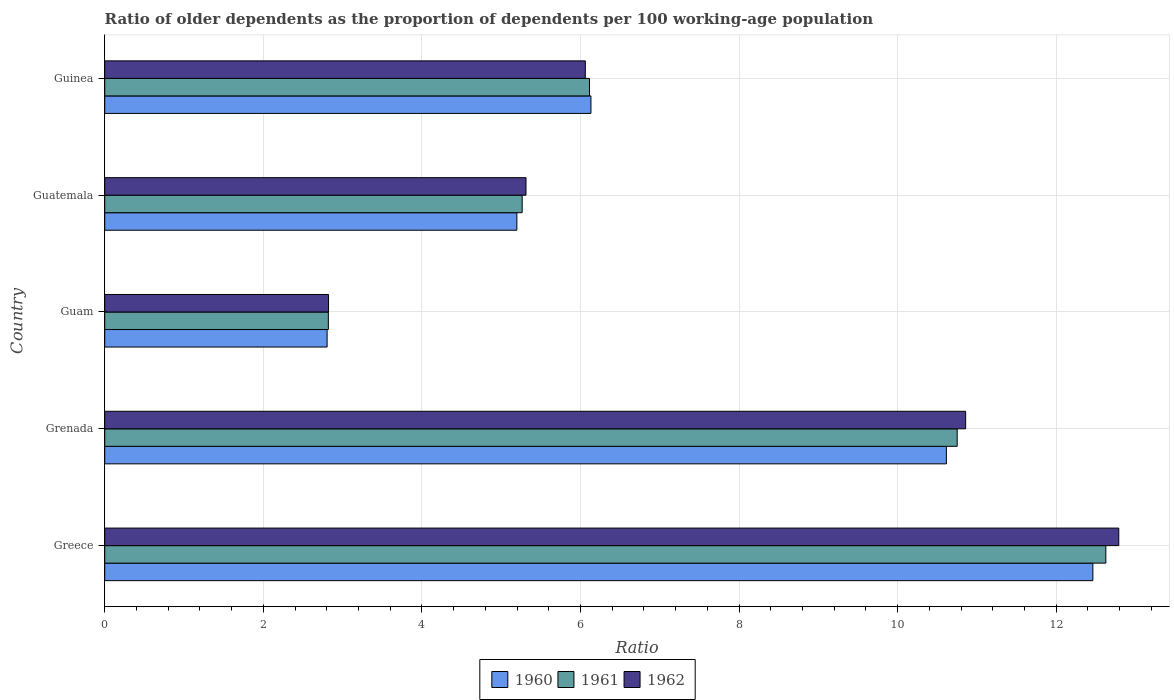How many groups of bars are there?
Give a very brief answer. 5. Are the number of bars per tick equal to the number of legend labels?
Your answer should be very brief. Yes. Are the number of bars on each tick of the Y-axis equal?
Give a very brief answer. Yes. How many bars are there on the 5th tick from the top?
Provide a short and direct response. 3. What is the label of the 3rd group of bars from the top?
Keep it short and to the point. Guam. What is the age dependency ratio(old) in 1961 in Greece?
Provide a short and direct response. 12.63. Across all countries, what is the maximum age dependency ratio(old) in 1960?
Your answer should be compact. 12.46. Across all countries, what is the minimum age dependency ratio(old) in 1962?
Give a very brief answer. 2.82. In which country was the age dependency ratio(old) in 1960 maximum?
Ensure brevity in your answer.  Greece. In which country was the age dependency ratio(old) in 1962 minimum?
Keep it short and to the point. Guam. What is the total age dependency ratio(old) in 1962 in the graph?
Your response must be concise. 37.84. What is the difference between the age dependency ratio(old) in 1960 in Greece and that in Grenada?
Keep it short and to the point. 1.85. What is the difference between the age dependency ratio(old) in 1960 in Guam and the age dependency ratio(old) in 1962 in Guinea?
Provide a succinct answer. -3.26. What is the average age dependency ratio(old) in 1960 per country?
Provide a succinct answer. 7.44. What is the difference between the age dependency ratio(old) in 1962 and age dependency ratio(old) in 1961 in Guatemala?
Give a very brief answer. 0.05. What is the ratio of the age dependency ratio(old) in 1962 in Grenada to that in Guinea?
Ensure brevity in your answer.  1.79. Is the age dependency ratio(old) in 1961 in Greece less than that in Guam?
Provide a short and direct response. No. Is the difference between the age dependency ratio(old) in 1962 in Grenada and Guinea greater than the difference between the age dependency ratio(old) in 1961 in Grenada and Guinea?
Your answer should be very brief. Yes. What is the difference between the highest and the second highest age dependency ratio(old) in 1961?
Offer a terse response. 1.87. What is the difference between the highest and the lowest age dependency ratio(old) in 1961?
Your answer should be compact. 9.81. In how many countries, is the age dependency ratio(old) in 1960 greater than the average age dependency ratio(old) in 1960 taken over all countries?
Offer a terse response. 2. Is the sum of the age dependency ratio(old) in 1962 in Grenada and Guinea greater than the maximum age dependency ratio(old) in 1960 across all countries?
Provide a succinct answer. Yes. What does the 1st bar from the top in Grenada represents?
Give a very brief answer. 1962. How many bars are there?
Keep it short and to the point. 15. How many countries are there in the graph?
Your answer should be compact. 5. What is the difference between two consecutive major ticks on the X-axis?
Your answer should be very brief. 2. Does the graph contain any zero values?
Keep it short and to the point. No. How many legend labels are there?
Your answer should be very brief. 3. How are the legend labels stacked?
Your response must be concise. Horizontal. What is the title of the graph?
Your response must be concise. Ratio of older dependents as the proportion of dependents per 100 working-age population. Does "1970" appear as one of the legend labels in the graph?
Provide a short and direct response. No. What is the label or title of the X-axis?
Your answer should be very brief. Ratio. What is the label or title of the Y-axis?
Make the answer very short. Country. What is the Ratio of 1960 in Greece?
Provide a short and direct response. 12.46. What is the Ratio of 1961 in Greece?
Make the answer very short. 12.63. What is the Ratio in 1962 in Greece?
Provide a short and direct response. 12.79. What is the Ratio in 1960 in Grenada?
Provide a succinct answer. 10.61. What is the Ratio in 1961 in Grenada?
Make the answer very short. 10.75. What is the Ratio in 1962 in Grenada?
Keep it short and to the point. 10.86. What is the Ratio of 1960 in Guam?
Provide a succinct answer. 2.8. What is the Ratio of 1961 in Guam?
Offer a terse response. 2.82. What is the Ratio in 1962 in Guam?
Give a very brief answer. 2.82. What is the Ratio in 1960 in Guatemala?
Offer a terse response. 5.2. What is the Ratio of 1961 in Guatemala?
Your answer should be compact. 5.26. What is the Ratio in 1962 in Guatemala?
Give a very brief answer. 5.31. What is the Ratio of 1960 in Guinea?
Your response must be concise. 6.13. What is the Ratio of 1961 in Guinea?
Provide a succinct answer. 6.11. What is the Ratio in 1962 in Guinea?
Make the answer very short. 6.06. Across all countries, what is the maximum Ratio of 1960?
Provide a succinct answer. 12.46. Across all countries, what is the maximum Ratio in 1961?
Offer a terse response. 12.63. Across all countries, what is the maximum Ratio of 1962?
Your response must be concise. 12.79. Across all countries, what is the minimum Ratio of 1960?
Offer a very short reply. 2.8. Across all countries, what is the minimum Ratio in 1961?
Your answer should be very brief. 2.82. Across all countries, what is the minimum Ratio in 1962?
Your answer should be very brief. 2.82. What is the total Ratio of 1960 in the graph?
Your answer should be compact. 37.21. What is the total Ratio in 1961 in the graph?
Keep it short and to the point. 37.57. What is the total Ratio of 1962 in the graph?
Provide a short and direct response. 37.84. What is the difference between the Ratio in 1960 in Greece and that in Grenada?
Your answer should be compact. 1.85. What is the difference between the Ratio in 1961 in Greece and that in Grenada?
Ensure brevity in your answer.  1.87. What is the difference between the Ratio in 1962 in Greece and that in Grenada?
Your answer should be very brief. 1.93. What is the difference between the Ratio in 1960 in Greece and that in Guam?
Provide a succinct answer. 9.66. What is the difference between the Ratio in 1961 in Greece and that in Guam?
Your answer should be very brief. 9.81. What is the difference between the Ratio of 1962 in Greece and that in Guam?
Give a very brief answer. 9.97. What is the difference between the Ratio of 1960 in Greece and that in Guatemala?
Your response must be concise. 7.26. What is the difference between the Ratio in 1961 in Greece and that in Guatemala?
Offer a terse response. 7.36. What is the difference between the Ratio in 1962 in Greece and that in Guatemala?
Keep it short and to the point. 7.48. What is the difference between the Ratio in 1960 in Greece and that in Guinea?
Provide a succinct answer. 6.33. What is the difference between the Ratio of 1961 in Greece and that in Guinea?
Your answer should be very brief. 6.51. What is the difference between the Ratio of 1962 in Greece and that in Guinea?
Make the answer very short. 6.73. What is the difference between the Ratio of 1960 in Grenada and that in Guam?
Ensure brevity in your answer.  7.81. What is the difference between the Ratio in 1961 in Grenada and that in Guam?
Provide a succinct answer. 7.93. What is the difference between the Ratio of 1962 in Grenada and that in Guam?
Provide a short and direct response. 8.03. What is the difference between the Ratio of 1960 in Grenada and that in Guatemala?
Your response must be concise. 5.42. What is the difference between the Ratio in 1961 in Grenada and that in Guatemala?
Give a very brief answer. 5.49. What is the difference between the Ratio in 1962 in Grenada and that in Guatemala?
Make the answer very short. 5.54. What is the difference between the Ratio in 1960 in Grenada and that in Guinea?
Your answer should be compact. 4.48. What is the difference between the Ratio of 1961 in Grenada and that in Guinea?
Offer a terse response. 4.64. What is the difference between the Ratio in 1962 in Grenada and that in Guinea?
Your response must be concise. 4.8. What is the difference between the Ratio of 1960 in Guam and that in Guatemala?
Your response must be concise. -2.39. What is the difference between the Ratio in 1961 in Guam and that in Guatemala?
Offer a very short reply. -2.44. What is the difference between the Ratio in 1962 in Guam and that in Guatemala?
Keep it short and to the point. -2.49. What is the difference between the Ratio of 1960 in Guam and that in Guinea?
Provide a short and direct response. -3.33. What is the difference between the Ratio in 1961 in Guam and that in Guinea?
Offer a terse response. -3.29. What is the difference between the Ratio of 1962 in Guam and that in Guinea?
Give a very brief answer. -3.24. What is the difference between the Ratio in 1960 in Guatemala and that in Guinea?
Your answer should be very brief. -0.93. What is the difference between the Ratio in 1961 in Guatemala and that in Guinea?
Ensure brevity in your answer.  -0.85. What is the difference between the Ratio of 1962 in Guatemala and that in Guinea?
Ensure brevity in your answer.  -0.75. What is the difference between the Ratio of 1960 in Greece and the Ratio of 1961 in Grenada?
Ensure brevity in your answer.  1.71. What is the difference between the Ratio in 1960 in Greece and the Ratio in 1962 in Grenada?
Your answer should be compact. 1.6. What is the difference between the Ratio of 1961 in Greece and the Ratio of 1962 in Grenada?
Offer a very short reply. 1.77. What is the difference between the Ratio of 1960 in Greece and the Ratio of 1961 in Guam?
Provide a short and direct response. 9.64. What is the difference between the Ratio of 1960 in Greece and the Ratio of 1962 in Guam?
Your answer should be compact. 9.64. What is the difference between the Ratio of 1961 in Greece and the Ratio of 1962 in Guam?
Your response must be concise. 9.8. What is the difference between the Ratio of 1960 in Greece and the Ratio of 1961 in Guatemala?
Ensure brevity in your answer.  7.2. What is the difference between the Ratio in 1960 in Greece and the Ratio in 1962 in Guatemala?
Your answer should be very brief. 7.15. What is the difference between the Ratio in 1961 in Greece and the Ratio in 1962 in Guatemala?
Provide a short and direct response. 7.31. What is the difference between the Ratio of 1960 in Greece and the Ratio of 1961 in Guinea?
Offer a terse response. 6.35. What is the difference between the Ratio in 1960 in Greece and the Ratio in 1962 in Guinea?
Offer a very short reply. 6.4. What is the difference between the Ratio in 1961 in Greece and the Ratio in 1962 in Guinea?
Provide a succinct answer. 6.56. What is the difference between the Ratio of 1960 in Grenada and the Ratio of 1961 in Guam?
Provide a succinct answer. 7.79. What is the difference between the Ratio of 1960 in Grenada and the Ratio of 1962 in Guam?
Ensure brevity in your answer.  7.79. What is the difference between the Ratio in 1961 in Grenada and the Ratio in 1962 in Guam?
Make the answer very short. 7.93. What is the difference between the Ratio of 1960 in Grenada and the Ratio of 1961 in Guatemala?
Provide a succinct answer. 5.35. What is the difference between the Ratio in 1960 in Grenada and the Ratio in 1962 in Guatemala?
Provide a succinct answer. 5.3. What is the difference between the Ratio of 1961 in Grenada and the Ratio of 1962 in Guatemala?
Offer a very short reply. 5.44. What is the difference between the Ratio in 1960 in Grenada and the Ratio in 1961 in Guinea?
Your response must be concise. 4.5. What is the difference between the Ratio of 1960 in Grenada and the Ratio of 1962 in Guinea?
Keep it short and to the point. 4.55. What is the difference between the Ratio of 1961 in Grenada and the Ratio of 1962 in Guinea?
Your answer should be compact. 4.69. What is the difference between the Ratio in 1960 in Guam and the Ratio in 1961 in Guatemala?
Offer a very short reply. -2.46. What is the difference between the Ratio of 1960 in Guam and the Ratio of 1962 in Guatemala?
Give a very brief answer. -2.51. What is the difference between the Ratio of 1961 in Guam and the Ratio of 1962 in Guatemala?
Keep it short and to the point. -2.49. What is the difference between the Ratio in 1960 in Guam and the Ratio in 1961 in Guinea?
Your answer should be compact. -3.31. What is the difference between the Ratio of 1960 in Guam and the Ratio of 1962 in Guinea?
Keep it short and to the point. -3.26. What is the difference between the Ratio of 1961 in Guam and the Ratio of 1962 in Guinea?
Offer a terse response. -3.24. What is the difference between the Ratio of 1960 in Guatemala and the Ratio of 1961 in Guinea?
Provide a succinct answer. -0.92. What is the difference between the Ratio of 1960 in Guatemala and the Ratio of 1962 in Guinea?
Keep it short and to the point. -0.86. What is the difference between the Ratio in 1961 in Guatemala and the Ratio in 1962 in Guinea?
Offer a very short reply. -0.8. What is the average Ratio in 1960 per country?
Offer a terse response. 7.44. What is the average Ratio in 1961 per country?
Ensure brevity in your answer.  7.51. What is the average Ratio of 1962 per country?
Ensure brevity in your answer.  7.57. What is the difference between the Ratio of 1960 and Ratio of 1961 in Greece?
Your answer should be compact. -0.16. What is the difference between the Ratio of 1960 and Ratio of 1962 in Greece?
Give a very brief answer. -0.33. What is the difference between the Ratio in 1961 and Ratio in 1962 in Greece?
Ensure brevity in your answer.  -0.16. What is the difference between the Ratio in 1960 and Ratio in 1961 in Grenada?
Keep it short and to the point. -0.14. What is the difference between the Ratio in 1960 and Ratio in 1962 in Grenada?
Your answer should be very brief. -0.24. What is the difference between the Ratio in 1961 and Ratio in 1962 in Grenada?
Make the answer very short. -0.11. What is the difference between the Ratio of 1960 and Ratio of 1961 in Guam?
Your response must be concise. -0.02. What is the difference between the Ratio of 1960 and Ratio of 1962 in Guam?
Your answer should be compact. -0.02. What is the difference between the Ratio in 1961 and Ratio in 1962 in Guam?
Provide a short and direct response. -0. What is the difference between the Ratio in 1960 and Ratio in 1961 in Guatemala?
Offer a very short reply. -0.07. What is the difference between the Ratio of 1960 and Ratio of 1962 in Guatemala?
Your answer should be compact. -0.12. What is the difference between the Ratio in 1961 and Ratio in 1962 in Guatemala?
Make the answer very short. -0.05. What is the difference between the Ratio in 1960 and Ratio in 1961 in Guinea?
Give a very brief answer. 0.02. What is the difference between the Ratio in 1960 and Ratio in 1962 in Guinea?
Provide a short and direct response. 0.07. What is the difference between the Ratio in 1961 and Ratio in 1962 in Guinea?
Provide a succinct answer. 0.05. What is the ratio of the Ratio in 1960 in Greece to that in Grenada?
Make the answer very short. 1.17. What is the ratio of the Ratio in 1961 in Greece to that in Grenada?
Provide a succinct answer. 1.17. What is the ratio of the Ratio of 1962 in Greece to that in Grenada?
Offer a very short reply. 1.18. What is the ratio of the Ratio in 1960 in Greece to that in Guam?
Provide a short and direct response. 4.44. What is the ratio of the Ratio in 1961 in Greece to that in Guam?
Your answer should be compact. 4.48. What is the ratio of the Ratio in 1962 in Greece to that in Guam?
Make the answer very short. 4.53. What is the ratio of the Ratio in 1960 in Greece to that in Guatemala?
Keep it short and to the point. 2.4. What is the ratio of the Ratio of 1961 in Greece to that in Guatemala?
Provide a succinct answer. 2.4. What is the ratio of the Ratio in 1962 in Greece to that in Guatemala?
Your answer should be compact. 2.41. What is the ratio of the Ratio of 1960 in Greece to that in Guinea?
Provide a short and direct response. 2.03. What is the ratio of the Ratio in 1961 in Greece to that in Guinea?
Provide a succinct answer. 2.07. What is the ratio of the Ratio of 1962 in Greece to that in Guinea?
Give a very brief answer. 2.11. What is the ratio of the Ratio in 1960 in Grenada to that in Guam?
Your answer should be compact. 3.78. What is the ratio of the Ratio in 1961 in Grenada to that in Guam?
Keep it short and to the point. 3.81. What is the ratio of the Ratio of 1962 in Grenada to that in Guam?
Offer a very short reply. 3.85. What is the ratio of the Ratio of 1960 in Grenada to that in Guatemala?
Provide a short and direct response. 2.04. What is the ratio of the Ratio in 1961 in Grenada to that in Guatemala?
Your answer should be compact. 2.04. What is the ratio of the Ratio in 1962 in Grenada to that in Guatemala?
Your answer should be compact. 2.04. What is the ratio of the Ratio in 1960 in Grenada to that in Guinea?
Offer a terse response. 1.73. What is the ratio of the Ratio in 1961 in Grenada to that in Guinea?
Keep it short and to the point. 1.76. What is the ratio of the Ratio of 1962 in Grenada to that in Guinea?
Ensure brevity in your answer.  1.79. What is the ratio of the Ratio of 1960 in Guam to that in Guatemala?
Provide a short and direct response. 0.54. What is the ratio of the Ratio in 1961 in Guam to that in Guatemala?
Give a very brief answer. 0.54. What is the ratio of the Ratio of 1962 in Guam to that in Guatemala?
Your answer should be compact. 0.53. What is the ratio of the Ratio of 1960 in Guam to that in Guinea?
Give a very brief answer. 0.46. What is the ratio of the Ratio of 1961 in Guam to that in Guinea?
Provide a short and direct response. 0.46. What is the ratio of the Ratio in 1962 in Guam to that in Guinea?
Provide a succinct answer. 0.47. What is the ratio of the Ratio of 1960 in Guatemala to that in Guinea?
Offer a terse response. 0.85. What is the ratio of the Ratio of 1961 in Guatemala to that in Guinea?
Offer a terse response. 0.86. What is the ratio of the Ratio in 1962 in Guatemala to that in Guinea?
Your response must be concise. 0.88. What is the difference between the highest and the second highest Ratio in 1960?
Provide a succinct answer. 1.85. What is the difference between the highest and the second highest Ratio in 1961?
Offer a terse response. 1.87. What is the difference between the highest and the second highest Ratio of 1962?
Make the answer very short. 1.93. What is the difference between the highest and the lowest Ratio in 1960?
Keep it short and to the point. 9.66. What is the difference between the highest and the lowest Ratio of 1961?
Provide a succinct answer. 9.81. What is the difference between the highest and the lowest Ratio of 1962?
Offer a very short reply. 9.97. 